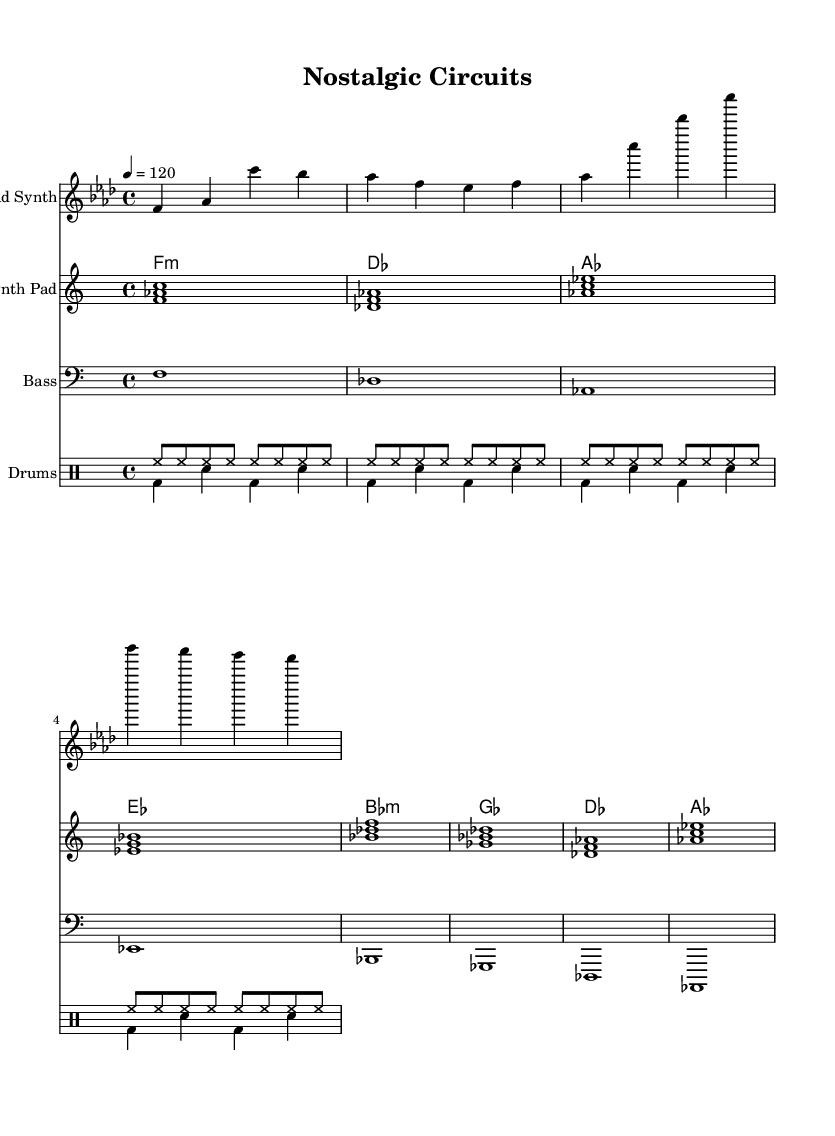What is the key signature of this music? The key signature is indicated by the sharp or flat symbols on the staff lines. In this case, the music is in F minor, which has four flats: B-flat, E-flat, A-flat, and D-flat.
Answer: F minor What is the time signature of this piece? The time signature is shown at the beginning of the score, right after the key signature. It is written as a fraction, with the number of beats per measure over the note value that receives one beat. Here, the time signature is 4/4, indicating there are four beats in each measure, and the quarter note receives one beat.
Answer: 4/4 What is the tempo of this composition? The tempo marking is indicated by the tempo text at the beginning of the score, which states how many beats per minute the piece should be played. In this score, it reads "4 = 120," meaning there are 120 quarter note beats per minute.
Answer: 120 What instruments are used in this piece? The instruments are listed at the beginning of each staff. In this score, there are a Lead Synth, Analog Synth Pad, Bass, and a Drum Staff, which includes two drum voices.
Answer: Lead Synth, Analog Synth Pad, Bass, Drums How many measures does the melody have? To determine the number of measures in the melody, count the vertical lines separating the measures in the melody part. The melody part contains four measures, indicated by the four vertical bar lines.
Answer: 4 What type of drum pattern is used in this piece? The drum patterns are specified in the drummode section. The "drumsUp" uses hi-hat hits in a consistent rhythmic pattern, while the "drumsDown" includes bass drum and snare hits in a more dynamic arrangement. This indicates a common dance rhythm with variations.
Answer: Hi-hat and bass/snare pattern Which chord appears most frequently in the harmony? Analyzing the chord progressions in the chordmode shows that the F minor chord appears frequently throughout the piece. Counting its occurrences, it is a primary element of the harmonic structure, often in the position of the tonic in the key.
Answer: F minor 